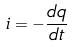Convert formula to latex. <formula><loc_0><loc_0><loc_500><loc_500>i = - \frac { d q } { d t }</formula> 